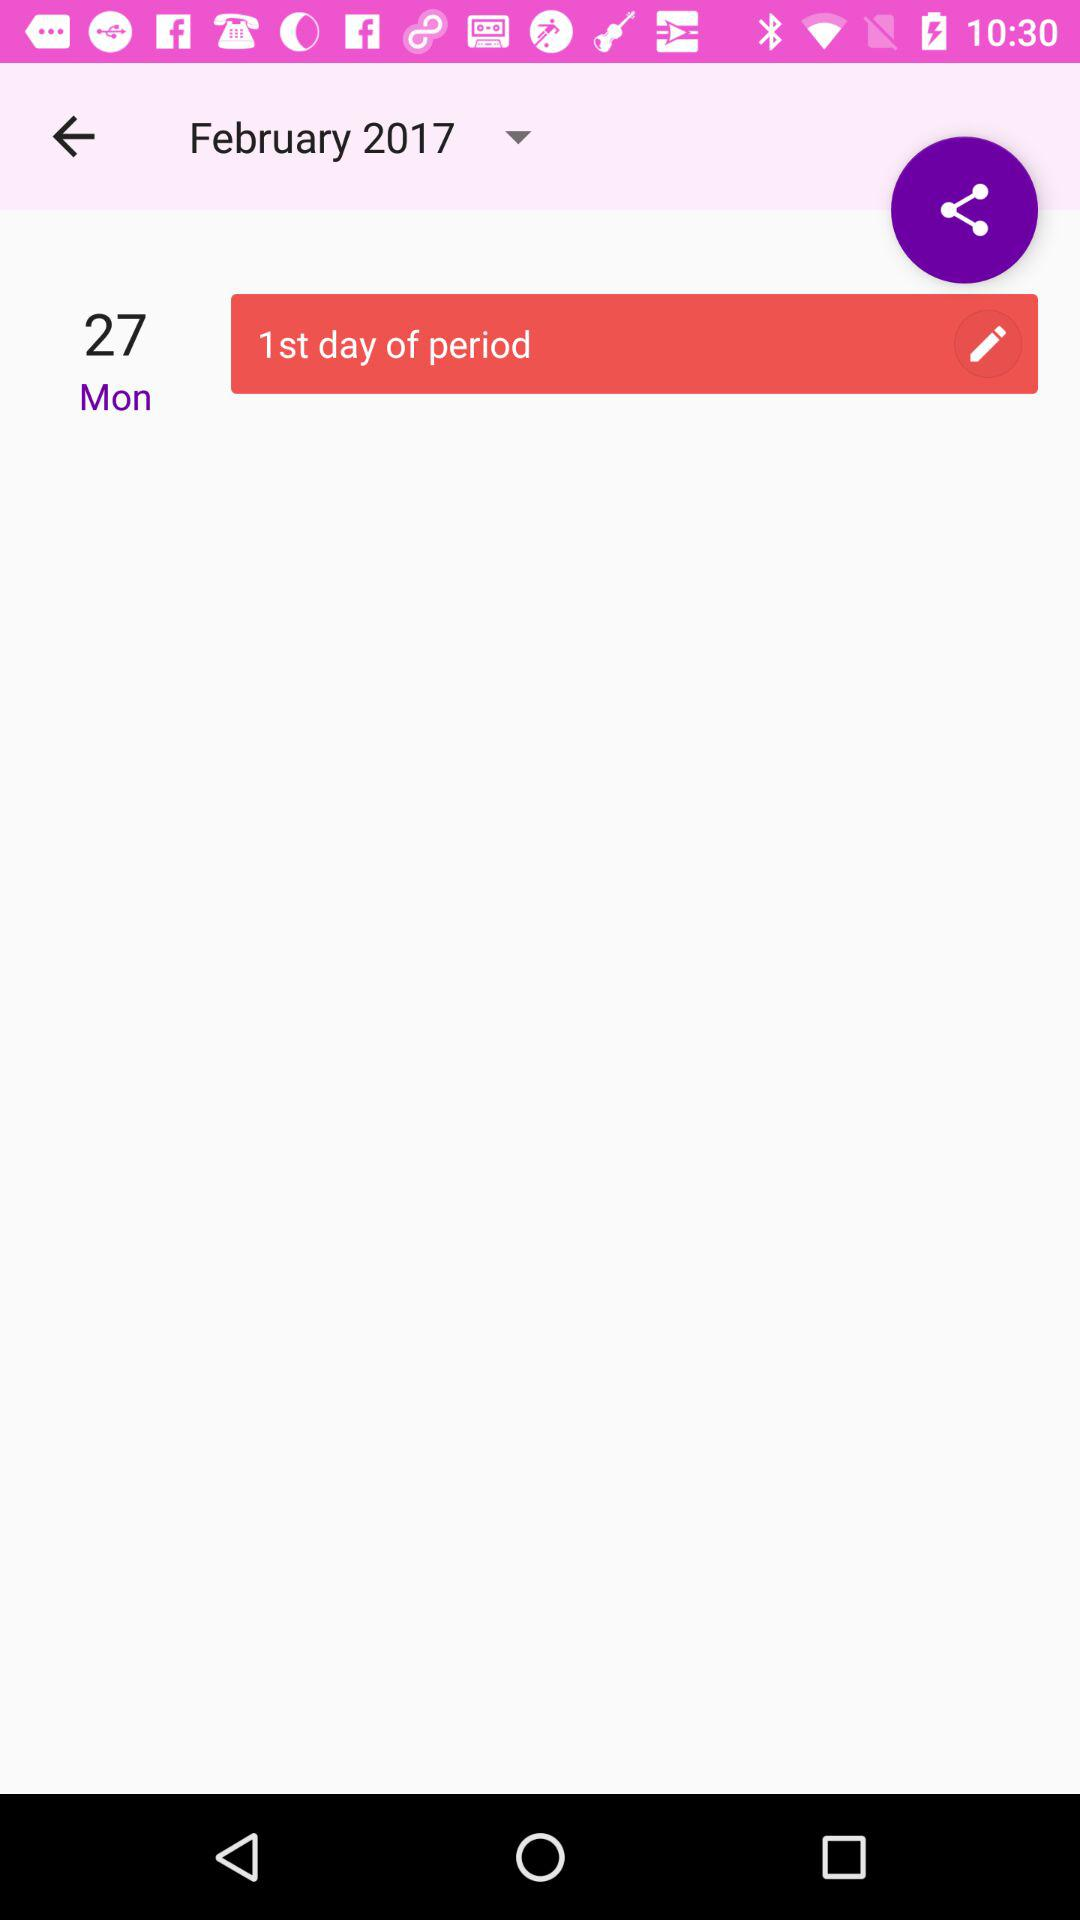What is the selected month? The selected month is February. 